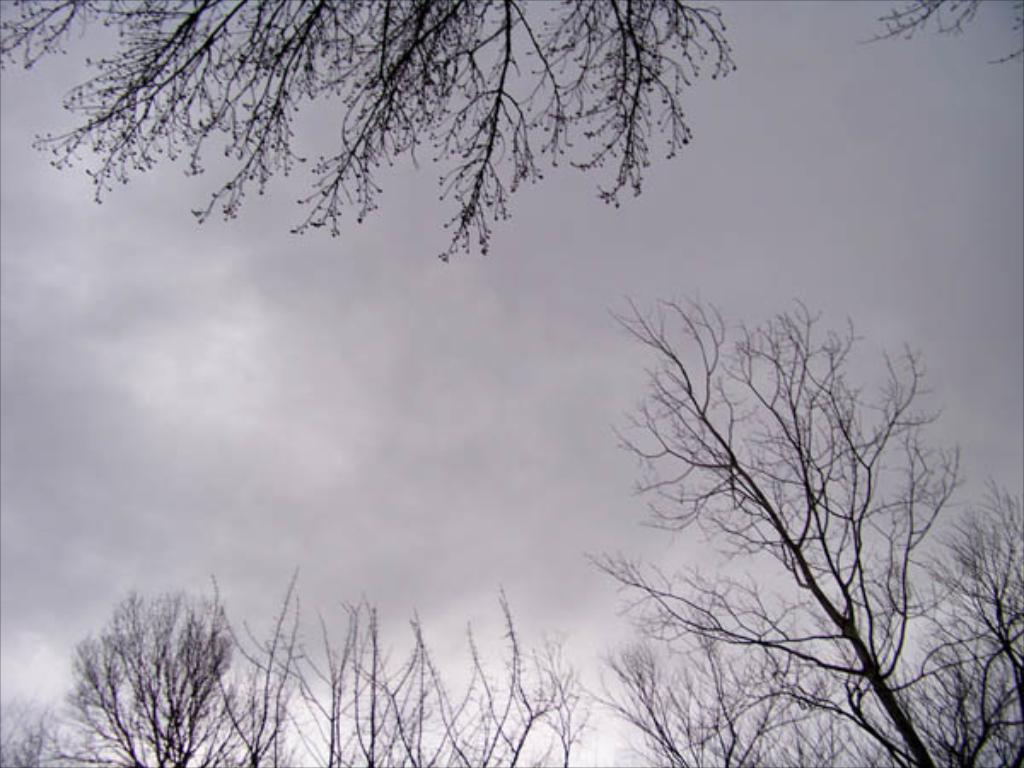What type of vegetation is present at the bottom of the image? There are trees at the bottom of the image. What type of vegetation is present at the top of the image? There are trees at the top of the image. What can be seen in the background of the image? The sky is visible in the background of the image. What type of calendar is hanging on the tree in the image? There is no calendar present in the image; it features trees at the top and bottom with the sky visible in the background. 